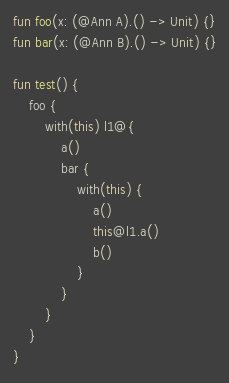<code> <loc_0><loc_0><loc_500><loc_500><_Kotlin_>fun foo(x: (@Ann A).() -> Unit) {}
fun bar(x: (@Ann B).() -> Unit) {}

fun test() {
    foo {
        with(this) l1@{
            a()
            bar {
                with(this) {
                    a()
                    this@l1.a()
                    b()
                }
            }
        }
    }
}
</code> 